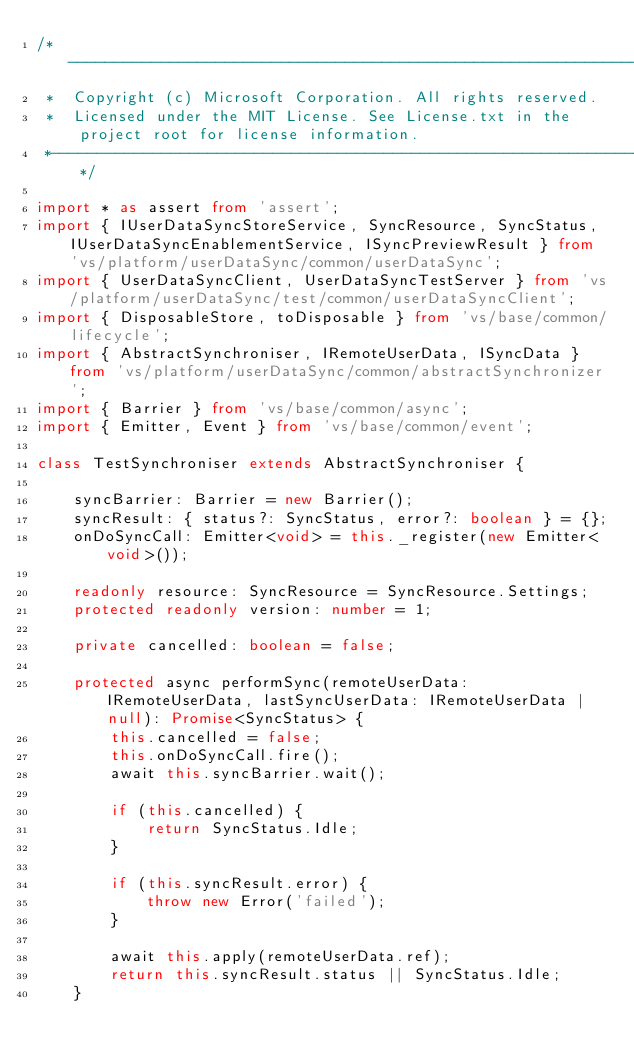Convert code to text. <code><loc_0><loc_0><loc_500><loc_500><_TypeScript_>/*---------------------------------------------------------------------------------------------
 *  Copyright (c) Microsoft Corporation. All rights reserved.
 *  Licensed under the MIT License. See License.txt in the project root for license information.
 *--------------------------------------------------------------------------------------------*/

import * as assert from 'assert';
import { IUserDataSyncStoreService, SyncResource, SyncStatus, IUserDataSyncEnablementService, ISyncPreviewResult } from 'vs/platform/userDataSync/common/userDataSync';
import { UserDataSyncClient, UserDataSyncTestServer } from 'vs/platform/userDataSync/test/common/userDataSyncClient';
import { DisposableStore, toDisposable } from 'vs/base/common/lifecycle';
import { AbstractSynchroniser, IRemoteUserData, ISyncData } from 'vs/platform/userDataSync/common/abstractSynchronizer';
import { Barrier } from 'vs/base/common/async';
import { Emitter, Event } from 'vs/base/common/event';

class TestSynchroniser extends AbstractSynchroniser {

	syncBarrier: Barrier = new Barrier();
	syncResult: { status?: SyncStatus, error?: boolean } = {};
	onDoSyncCall: Emitter<void> = this._register(new Emitter<void>());

	readonly resource: SyncResource = SyncResource.Settings;
	protected readonly version: number = 1;

	private cancelled: boolean = false;

	protected async performSync(remoteUserData: IRemoteUserData, lastSyncUserData: IRemoteUserData | null): Promise<SyncStatus> {
		this.cancelled = false;
		this.onDoSyncCall.fire();
		await this.syncBarrier.wait();

		if (this.cancelled) {
			return SyncStatus.Idle;
		}

		if (this.syncResult.error) {
			throw new Error('failed');
		}

		await this.apply(remoteUserData.ref);
		return this.syncResult.status || SyncStatus.Idle;
	}
</code> 